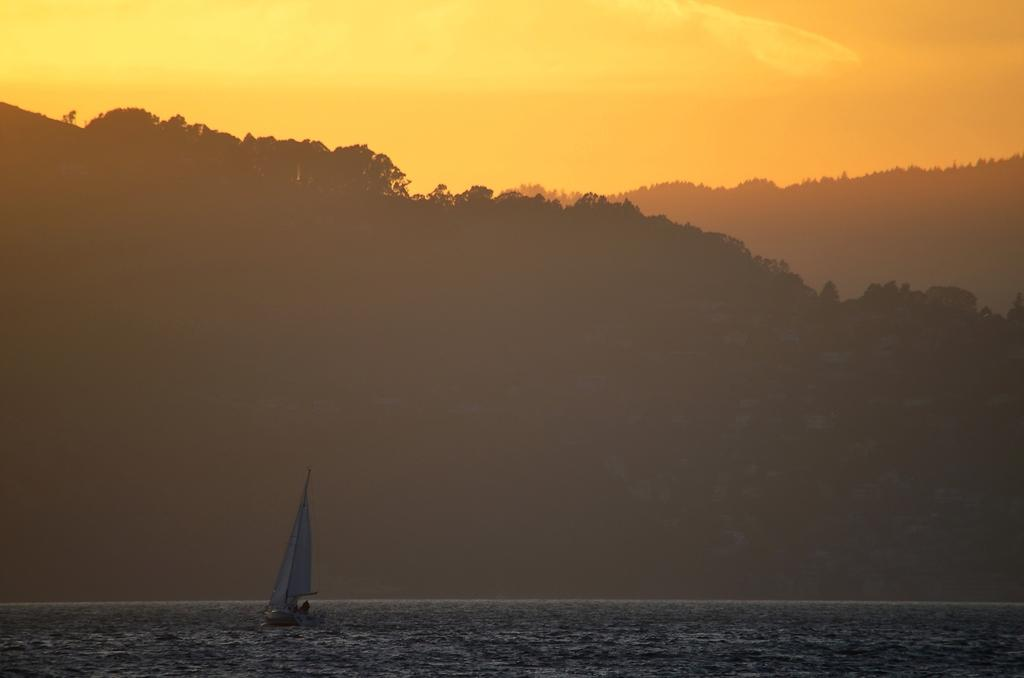What is the main subject of the image? There is a boat sailing on the water in the image. What can be seen in the background of the image? There are mountains in the background of the image. How are the mountains described? The mountains are covered with trees. What is the condition of the sky in the image? The sky is clear in the image. How many cakes are being carried in the boat in the image? There are no cakes present in the image; it features a boat sailing on the water with mountains and trees in the background. Is there a bag visible on the boat in the image? There is no bag visible on the boat in the image. 